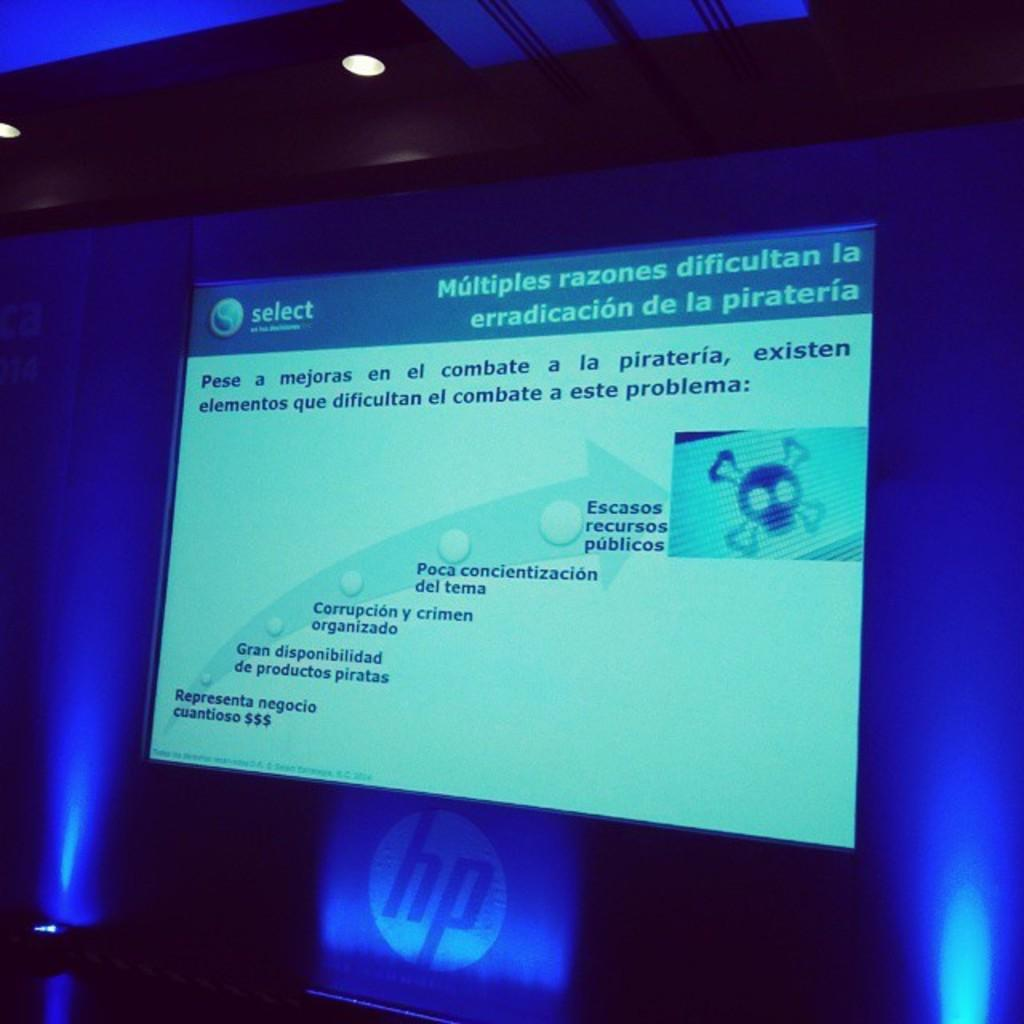<image>
Offer a succinct explanation of the picture presented. A large screen shows the word "select" in the upper left corner. 